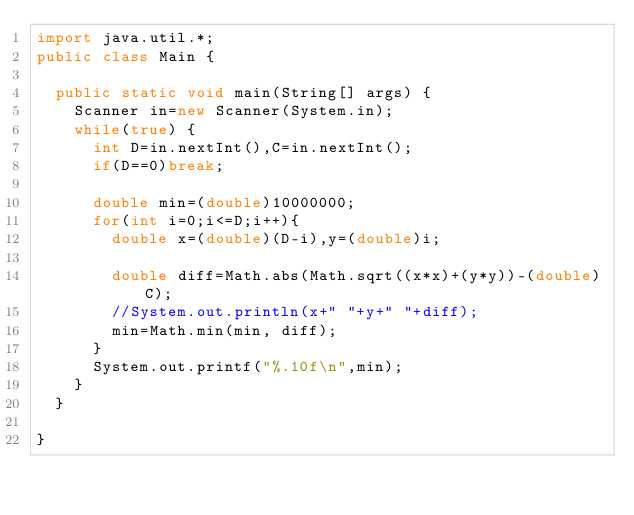<code> <loc_0><loc_0><loc_500><loc_500><_Java_>import java.util.*;
public class Main {

	public static void main(String[] args) {
		Scanner in=new Scanner(System.in);
		while(true) {
			int D=in.nextInt(),C=in.nextInt();
			if(D==0)break;
			
			double min=(double)10000000;
			for(int i=0;i<=D;i++){
				double x=(double)(D-i),y=(double)i;
				
				double diff=Math.abs(Math.sqrt((x*x)+(y*y))-(double)C);
				//System.out.println(x+" "+y+" "+diff);
				min=Math.min(min, diff);
			}
			System.out.printf("%.10f\n",min);
		}
	}

}

</code> 